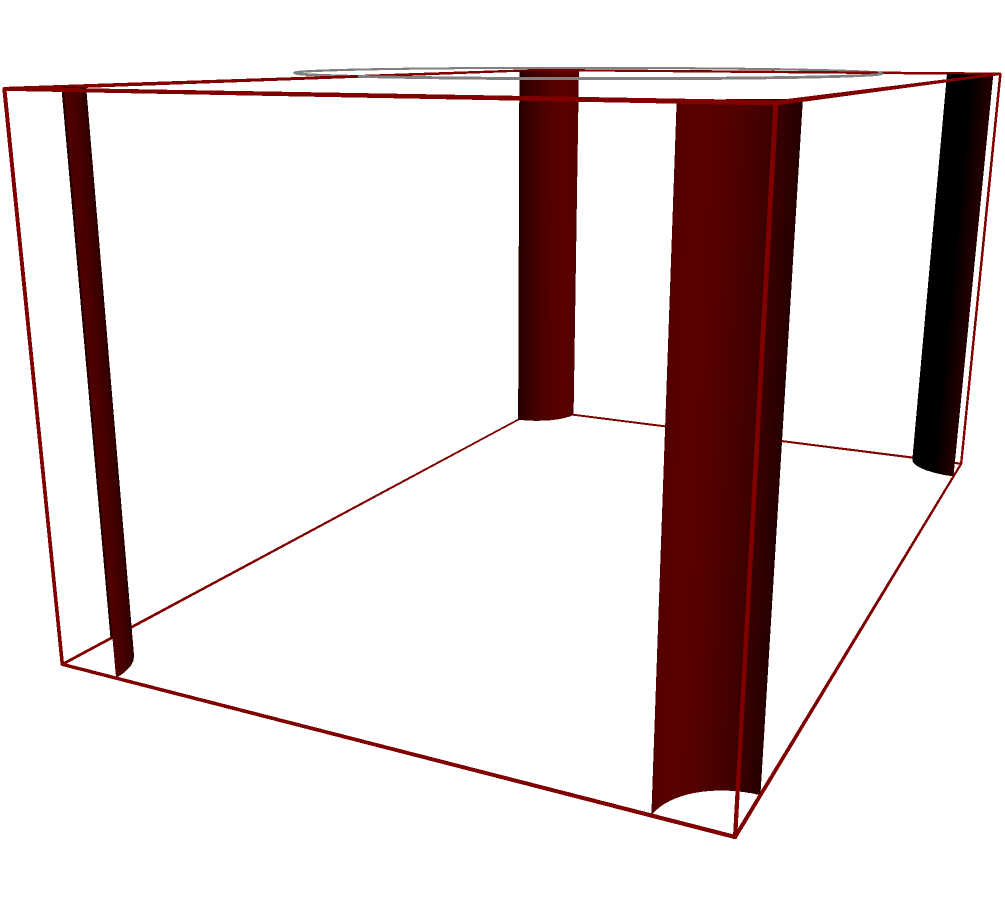Your beloved Jim Reeves songs used to play on a retro radio with a wooden cabinet. The cabinet has a rectangular shape with rounded edges, as shown in the diagram. The main body measures 8 inches in length, 5 inches in width, and 4 inches in height. The edges are rounded with a radius of 0.5 inches. What is the volume of the wooden cabinet in cubic inches? Let's approach this step-by-step:

1) First, calculate the volume of the rectangular prism without considering the rounded edges:
   $$V_{rect} = l \times w \times h = 8 \times 5 \times 4 = 160 \text{ in}^3$$

2) Now, we need to subtract the volume of the rounded edges. There are 12 edges in total (4 vertical, 4 horizontal on top, 4 horizontal on bottom).

3) The volume of one rounded edge is the difference between a rectangular prism and a cylinder:
   $$V_{edge} = l \times r^2 - \frac{\pi}{4} \times l \times r^2$$
   where $l$ is the length of the edge and $r$ is the radius of the rounded part.

4) For the 4 vertical edges: $l = 4$ inches
   $$V_{vertical} = 4 \times (4 \times 0.5^2 - \frac{\pi}{4} \times 4 \times 0.5^2) = 4 \times (1 - \frac{\pi}{4}) \text{ in}^3$$

5) For the 8 horizontal edges: $l = 8$ inches for 4 edges, and $l = 5$ inches for the other 4
   $$V_{horizontal} = 4 \times (8 \times 0.5^2 - \frac{\pi}{4} \times 8 \times 0.5^2) + 4 \times (5 \times 0.5^2 - \frac{\pi}{4} \times 5 \times 0.5^2)$$
   $$= 4 \times (2 - \frac{\pi}{2}) + 4 \times (1.25 - \frac{5\pi}{16}) \text{ in}^3$$

6) Total volume subtracted due to rounded edges:
   $$V_{subtracted} = 4 \times (1 - \frac{\pi}{4}) + 4 \times (2 - \frac{\pi}{2}) + 4 \times (1.25 - \frac{5\pi}{16})$$
   $$= 4 \times (4.25 - \frac{13\pi}{16}) \text{ in}^3$$

7) The final volume is:
   $$V_{final} = V_{rect} - V_{subtracted}$$
   $$= 160 - 4 \times (4.25 - \frac{13\pi}{16})$$
   $$\approx 154.69 \text{ in}^3$$
Answer: 154.69 cubic inches 